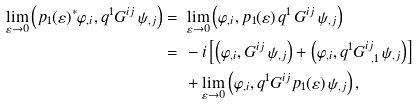<formula> <loc_0><loc_0><loc_500><loc_500>\lim _ { \varepsilon \to 0 } \left ( p _ { 1 } ( \varepsilon ) ^ { * } \varphi _ { , i } , q ^ { 1 } G ^ { i j } \, \psi _ { , j } \right ) = & \ \lim _ { \varepsilon \to 0 } \left ( \varphi _ { , i } , p _ { 1 } ( \varepsilon ) \, q ^ { 1 } \, G ^ { i j } \, \psi _ { , j } \right ) \\ = & \ - i \left [ \left ( \varphi _ { , i } , G ^ { i j } \, \psi _ { , j } \right ) + \left ( \varphi _ { , i } , q ^ { 1 } G ^ { i j } _ { \ , 1 } \, \psi _ { , j } \right ) \right ] \\ & \ + \lim _ { \varepsilon \to 0 } \left ( \varphi _ { , i } , q ^ { 1 } G ^ { i j } p _ { 1 } ( \varepsilon ) \, \psi _ { , j } \right ) ,</formula> 